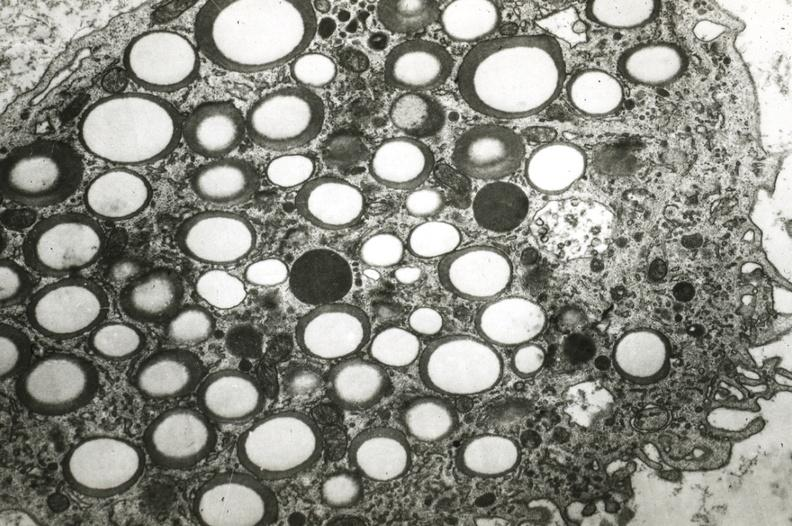s coronary artery present?
Answer the question using a single word or phrase. Yes 